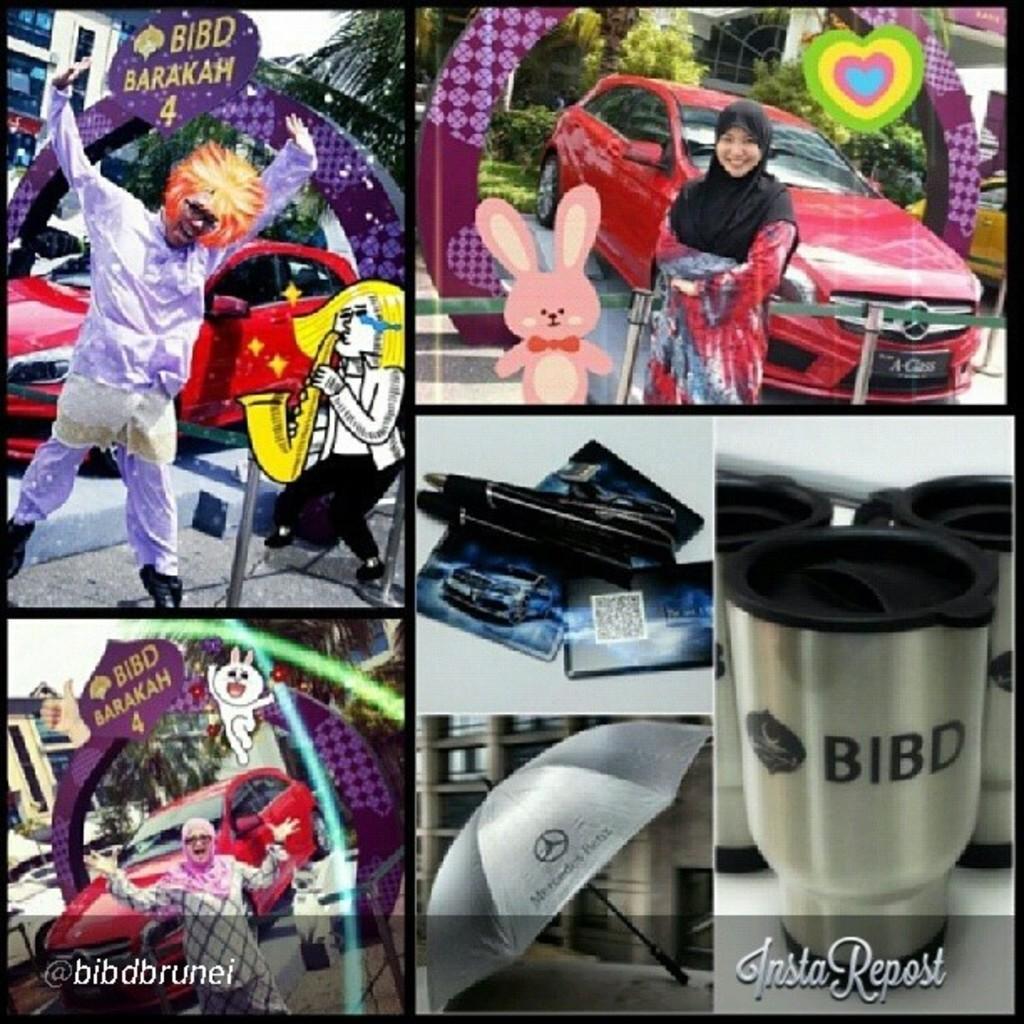Describe this image in one or two sentences. This is a photo grid image, on the left side top corner there is a man standing on side of road behind a anime, beside it there is a woman standing in front of a car and on the bottom there is steel bottle and beside it there is umbrella and other pic above with pen and cards, on the left side bottom there is an old man standing in front of red car in front of an arch. 